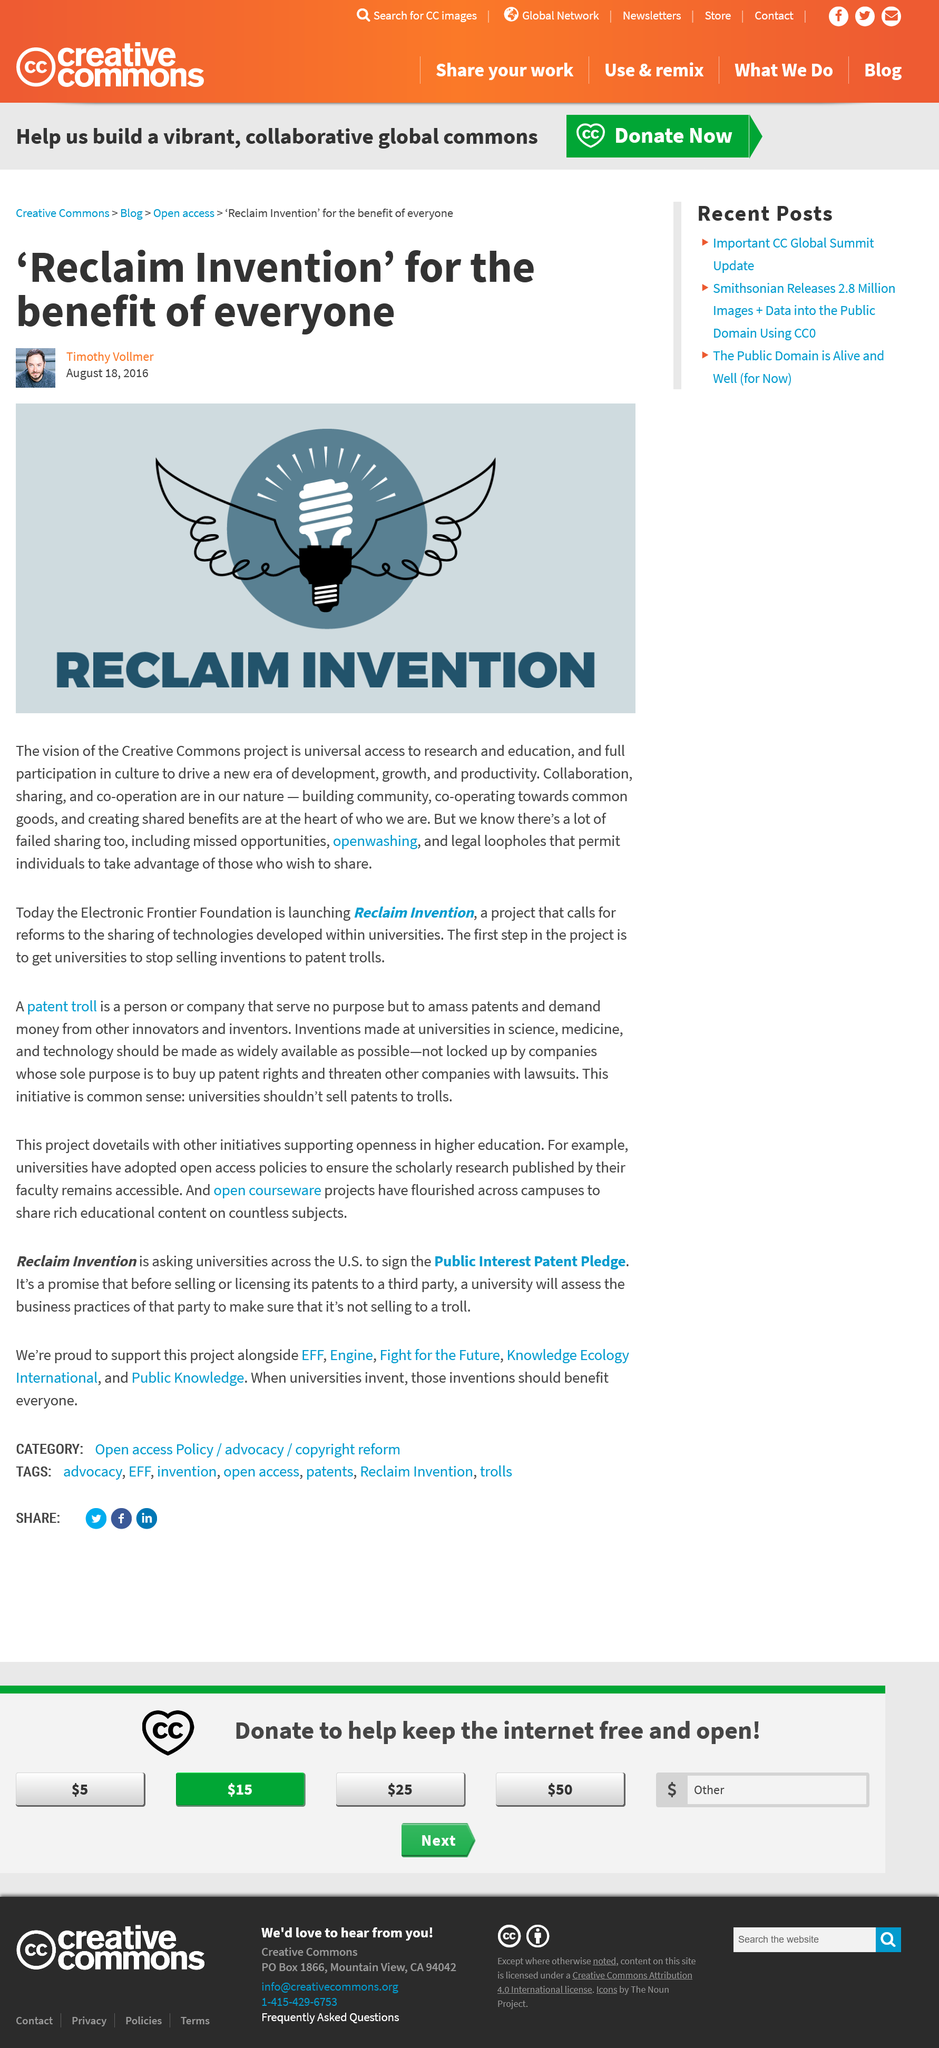Identify some key points in this picture. Reclaim Invention holds collaboration, sharing, and co-operation as core attributes to its ethos, fostering creativity and innovation in the workplace through teamwork and mutual support. This Creative Commons project aims to achieve universal access to research and education through its vision. This Creative Commons project is for the benefit of all individuals, promoting access and use for the general public. 